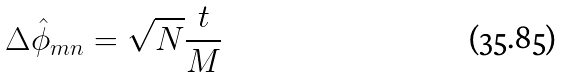Convert formula to latex. <formula><loc_0><loc_0><loc_500><loc_500>\Delta \hat { \phi } _ { m n } = \sqrt { N } \frac { t } { M }</formula> 